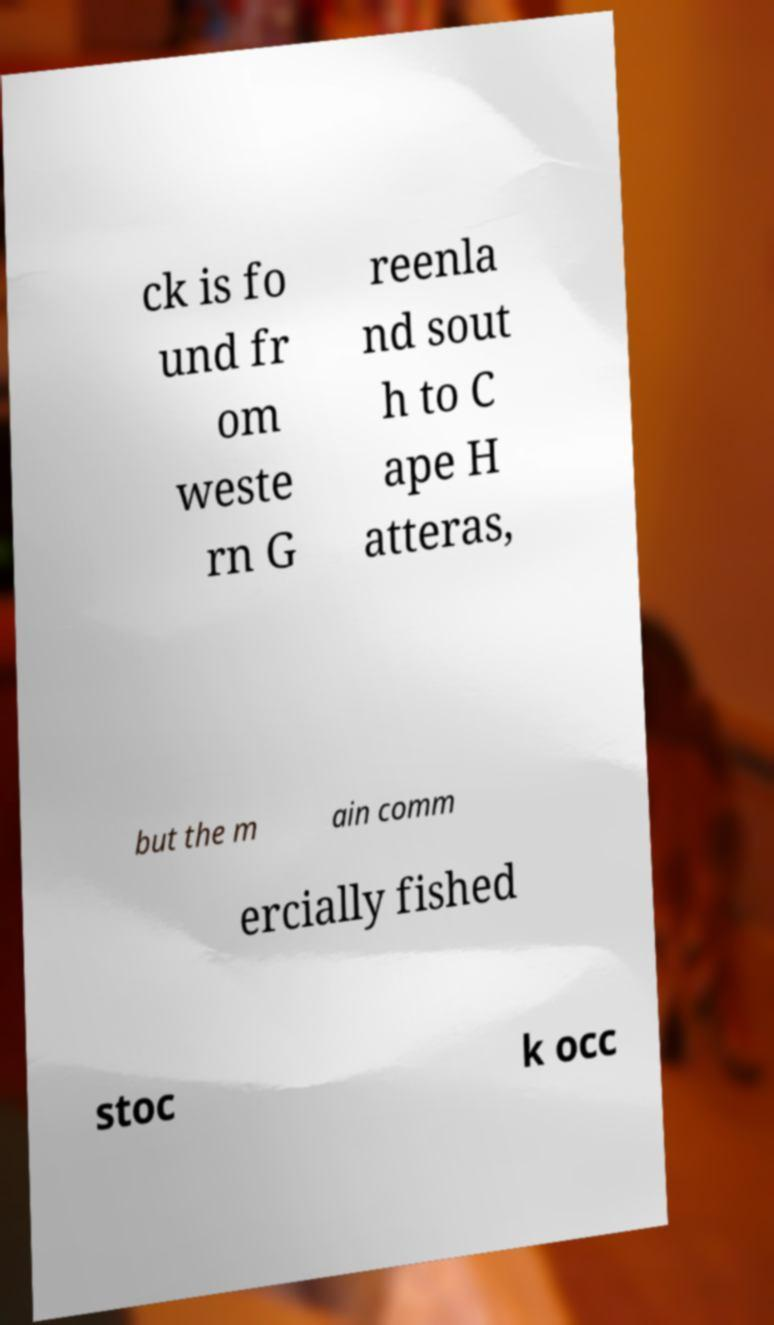I need the written content from this picture converted into text. Can you do that? ck is fo und fr om weste rn G reenla nd sout h to C ape H atteras, but the m ain comm ercially fished stoc k occ 